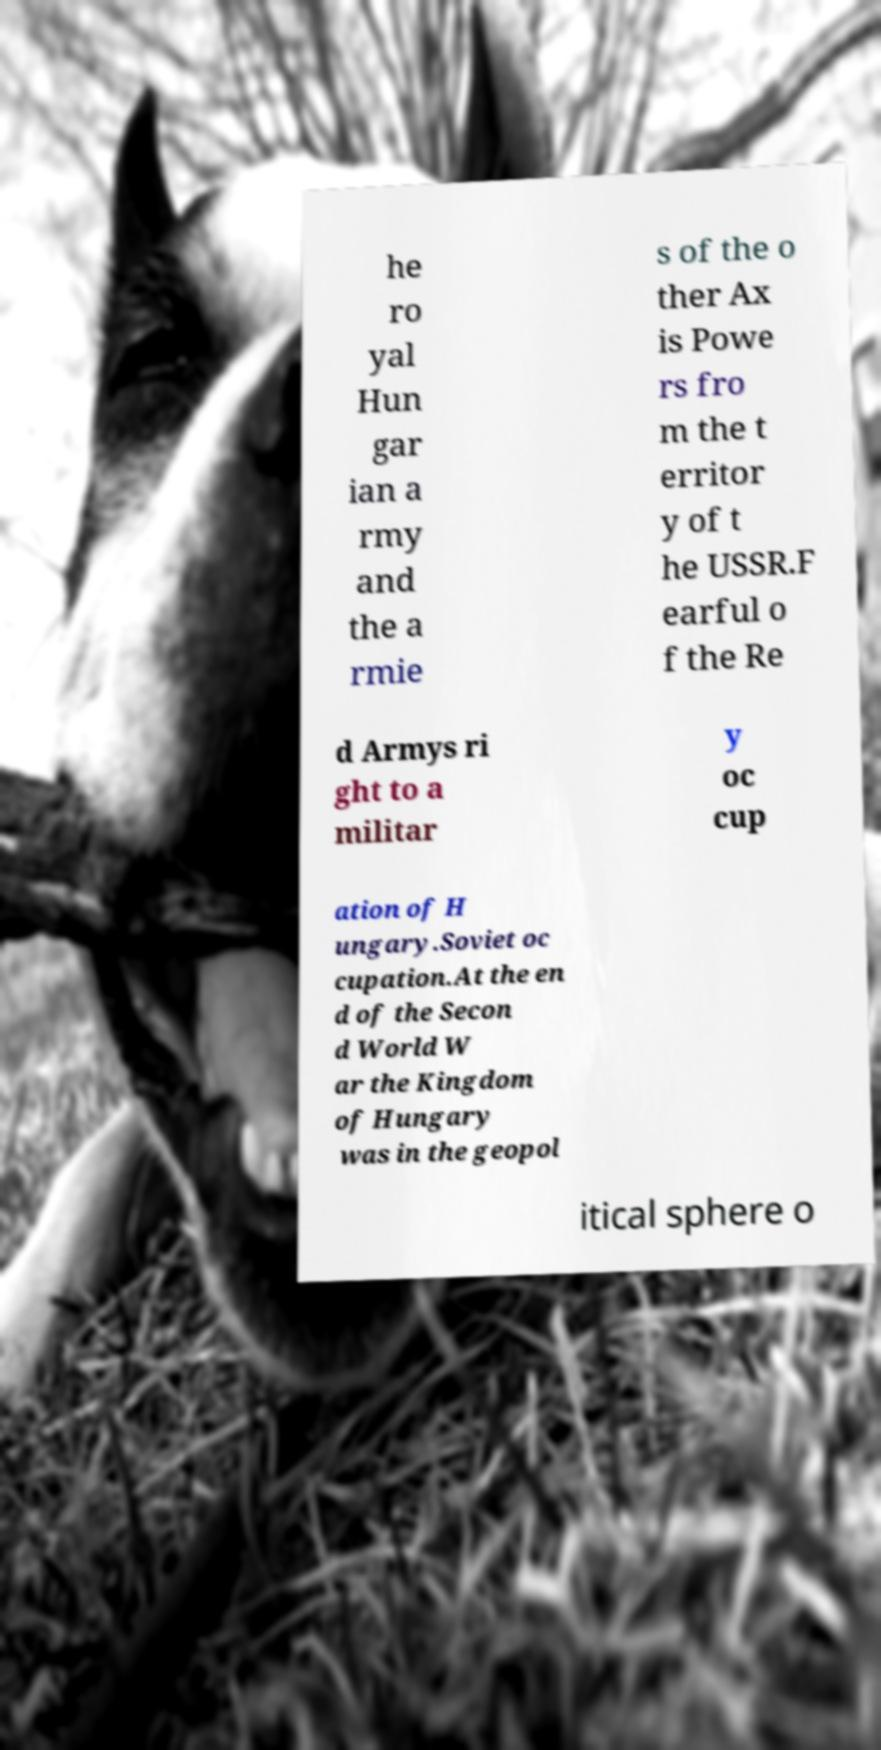Can you read and provide the text displayed in the image?This photo seems to have some interesting text. Can you extract and type it out for me? he ro yal Hun gar ian a rmy and the a rmie s of the o ther Ax is Powe rs fro m the t erritor y of t he USSR.F earful o f the Re d Armys ri ght to a militar y oc cup ation of H ungary.Soviet oc cupation.At the en d of the Secon d World W ar the Kingdom of Hungary was in the geopol itical sphere o 